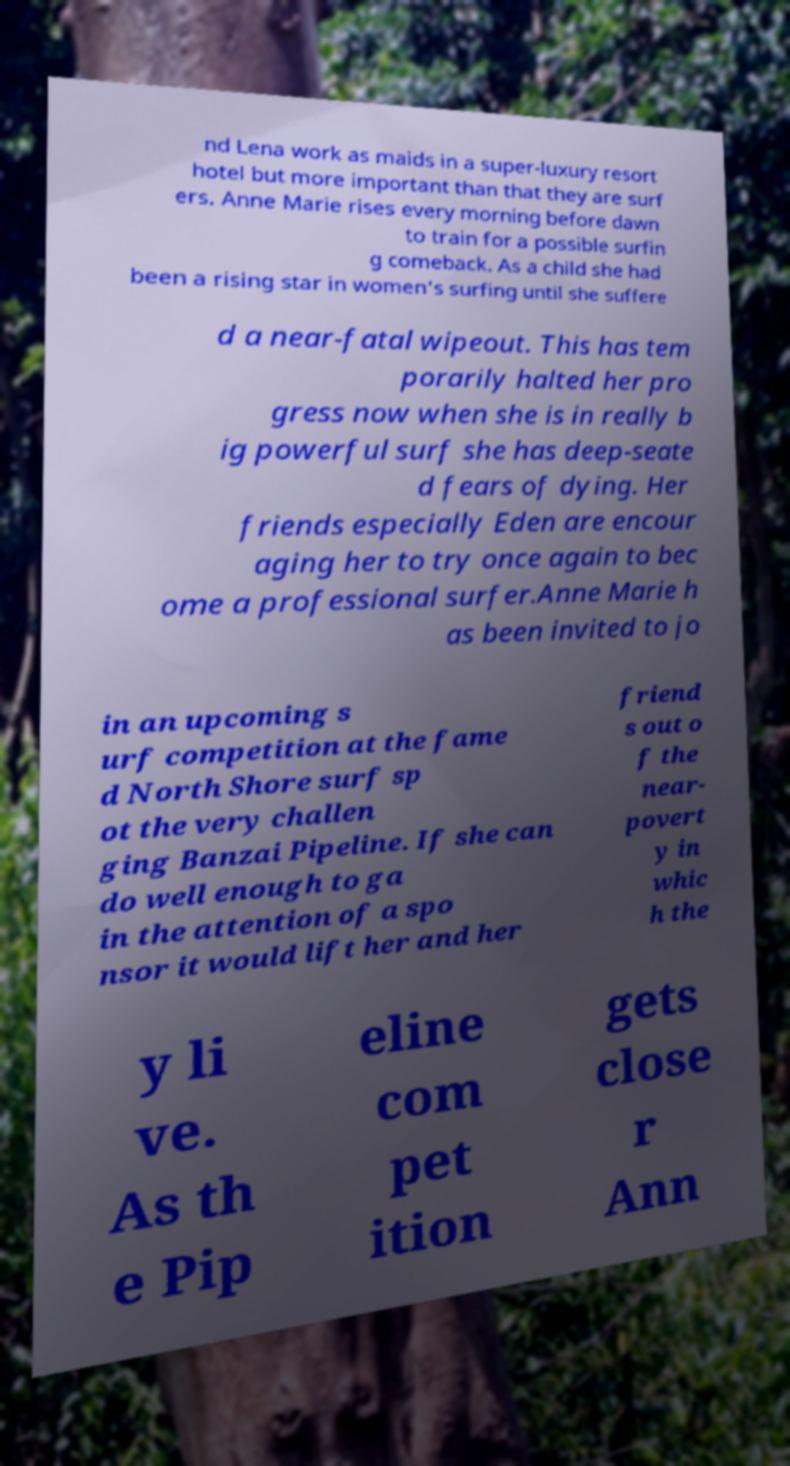Can you accurately transcribe the text from the provided image for me? nd Lena work as maids in a super-luxury resort hotel but more important than that they are surf ers. Anne Marie rises every morning before dawn to train for a possible surfin g comeback. As a child she had been a rising star in women's surfing until she suffere d a near-fatal wipeout. This has tem porarily halted her pro gress now when she is in really b ig powerful surf she has deep-seate d fears of dying. Her friends especially Eden are encour aging her to try once again to bec ome a professional surfer.Anne Marie h as been invited to jo in an upcoming s urf competition at the fame d North Shore surf sp ot the very challen ging Banzai Pipeline. If she can do well enough to ga in the attention of a spo nsor it would lift her and her friend s out o f the near- povert y in whic h the y li ve. As th e Pip eline com pet ition gets close r Ann 